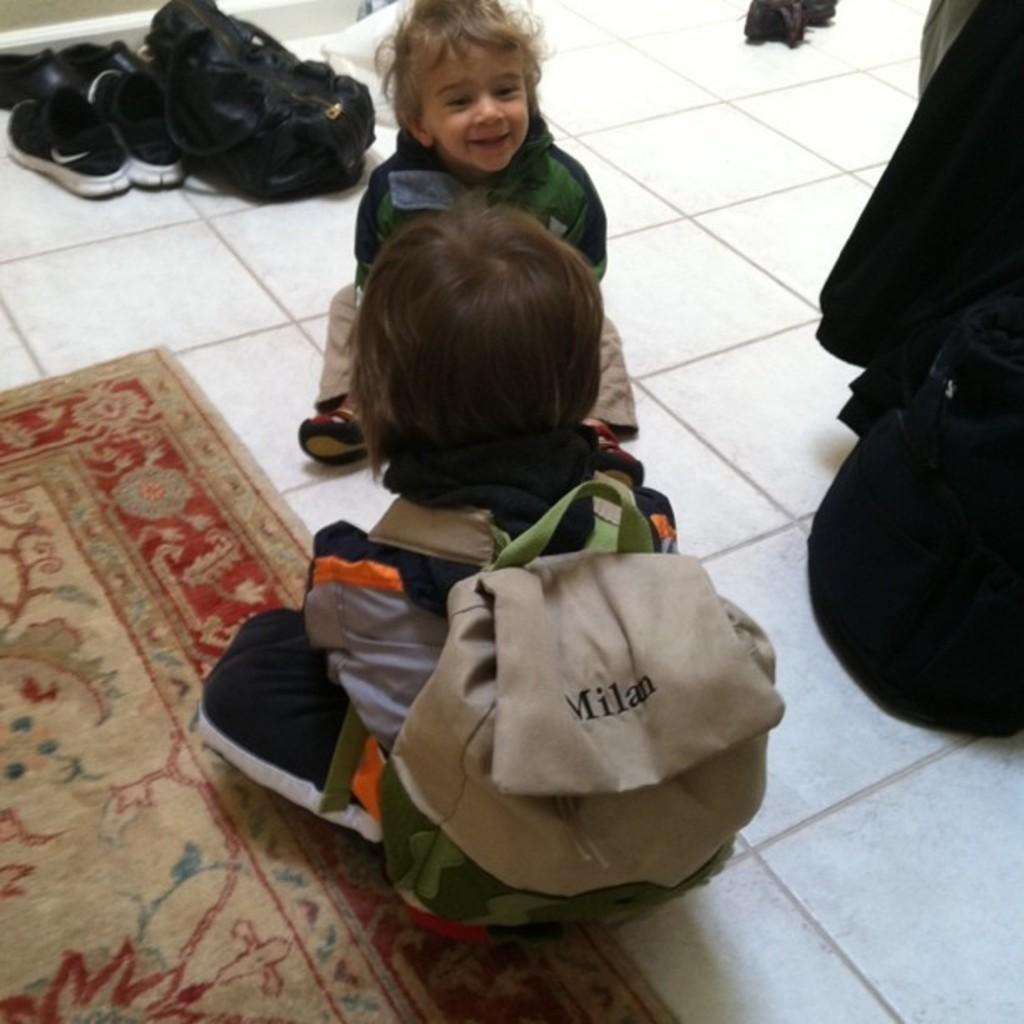What name is on the kid's backpack?
Provide a short and direct response. Milan. 